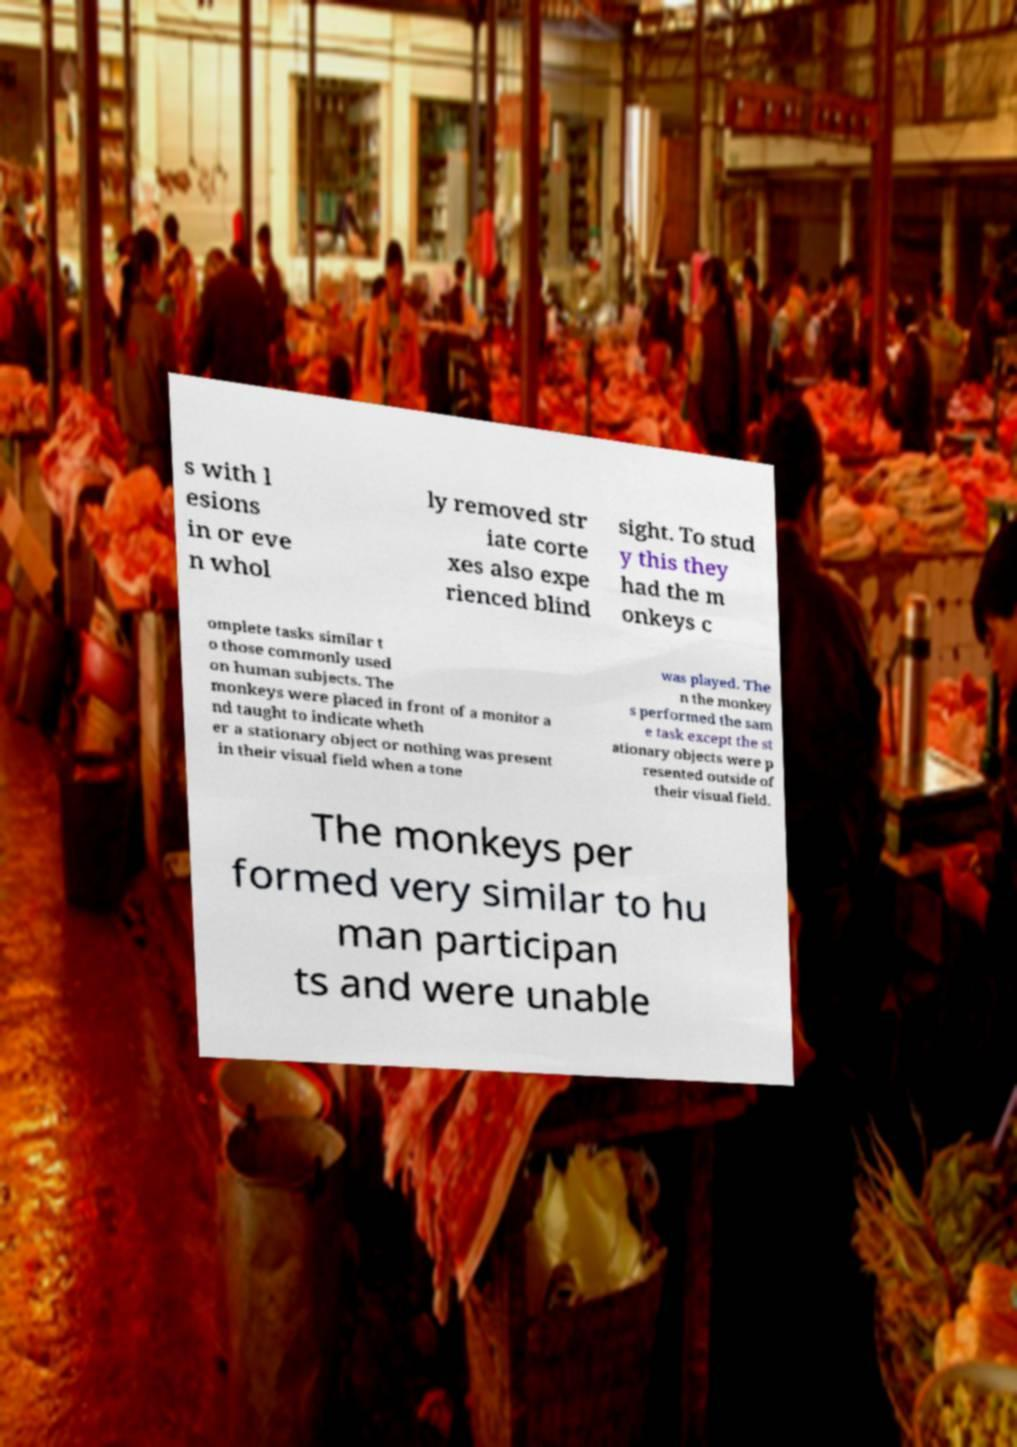Can you read and provide the text displayed in the image?This photo seems to have some interesting text. Can you extract and type it out for me? s with l esions in or eve n whol ly removed str iate corte xes also expe rienced blind sight. To stud y this they had the m onkeys c omplete tasks similar t o those commonly used on human subjects. The monkeys were placed in front of a monitor a nd taught to indicate wheth er a stationary object or nothing was present in their visual field when a tone was played. The n the monkey s performed the sam e task except the st ationary objects were p resented outside of their visual field. The monkeys per formed very similar to hu man participan ts and were unable 